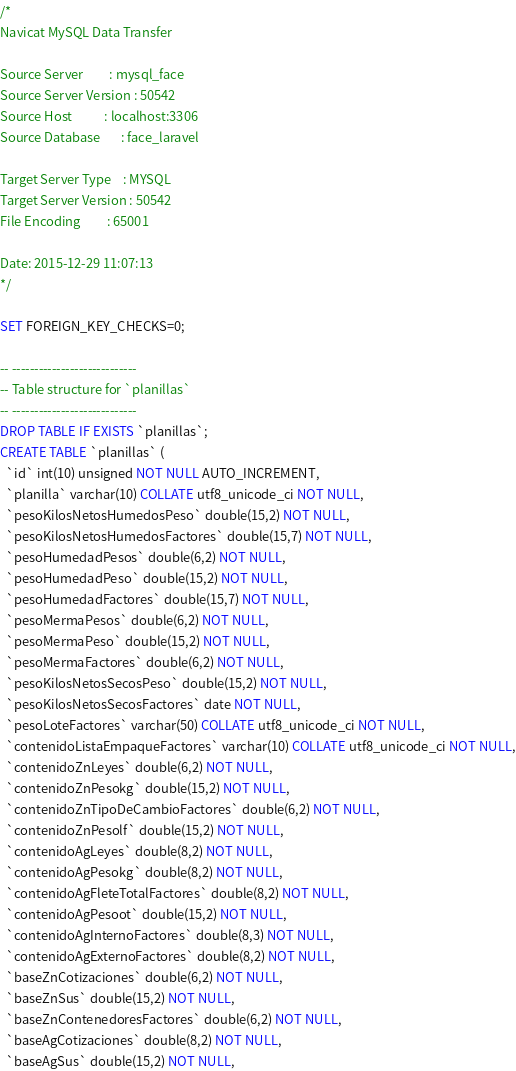<code> <loc_0><loc_0><loc_500><loc_500><_SQL_>/*
Navicat MySQL Data Transfer

Source Server         : mysql_face
Source Server Version : 50542
Source Host           : localhost:3306
Source Database       : face_laravel

Target Server Type    : MYSQL
Target Server Version : 50542
File Encoding         : 65001

Date: 2015-12-29 11:07:13
*/

SET FOREIGN_KEY_CHECKS=0;

-- ----------------------------
-- Table structure for `planillas`
-- ----------------------------
DROP TABLE IF EXISTS `planillas`;
CREATE TABLE `planillas` (
  `id` int(10) unsigned NOT NULL AUTO_INCREMENT,
  `planilla` varchar(10) COLLATE utf8_unicode_ci NOT NULL,
  `pesoKilosNetosHumedosPeso` double(15,2) NOT NULL,
  `pesoKilosNetosHumedosFactores` double(15,7) NOT NULL,
  `pesoHumedadPesos` double(6,2) NOT NULL,
  `pesoHumedadPeso` double(15,2) NOT NULL,
  `pesoHumedadFactores` double(15,7) NOT NULL,
  `pesoMermaPesos` double(6,2) NOT NULL,
  `pesoMermaPeso` double(15,2) NOT NULL,
  `pesoMermaFactores` double(6,2) NOT NULL,
  `pesoKilosNetosSecosPeso` double(15,2) NOT NULL,
  `pesoKilosNetosSecosFactores` date NOT NULL,
  `pesoLoteFactores` varchar(50) COLLATE utf8_unicode_ci NOT NULL,
  `contenidoListaEmpaqueFactores` varchar(10) COLLATE utf8_unicode_ci NOT NULL,
  `contenidoZnLeyes` double(6,2) NOT NULL,
  `contenidoZnPesokg` double(15,2) NOT NULL,
  `contenidoZnTipoDeCambioFactores` double(6,2) NOT NULL,
  `contenidoZnPesolf` double(15,2) NOT NULL,
  `contenidoAgLeyes` double(8,2) NOT NULL,
  `contenidoAgPesokg` double(8,2) NOT NULL,
  `contenidoAgFleteTotalFactores` double(8,2) NOT NULL,
  `contenidoAgPesoot` double(15,2) NOT NULL,
  `contenidoAgInternoFactores` double(8,3) NOT NULL,
  `contenidoAgExternoFactores` double(8,2) NOT NULL,
  `baseZnCotizaciones` double(6,2) NOT NULL,
  `baseZnSus` double(15,2) NOT NULL,
  `baseZnContenedoresFactores` double(6,2) NOT NULL,
  `baseAgCotizaciones` double(8,2) NOT NULL,
  `baseAgSus` double(15,2) NOT NULL,</code> 